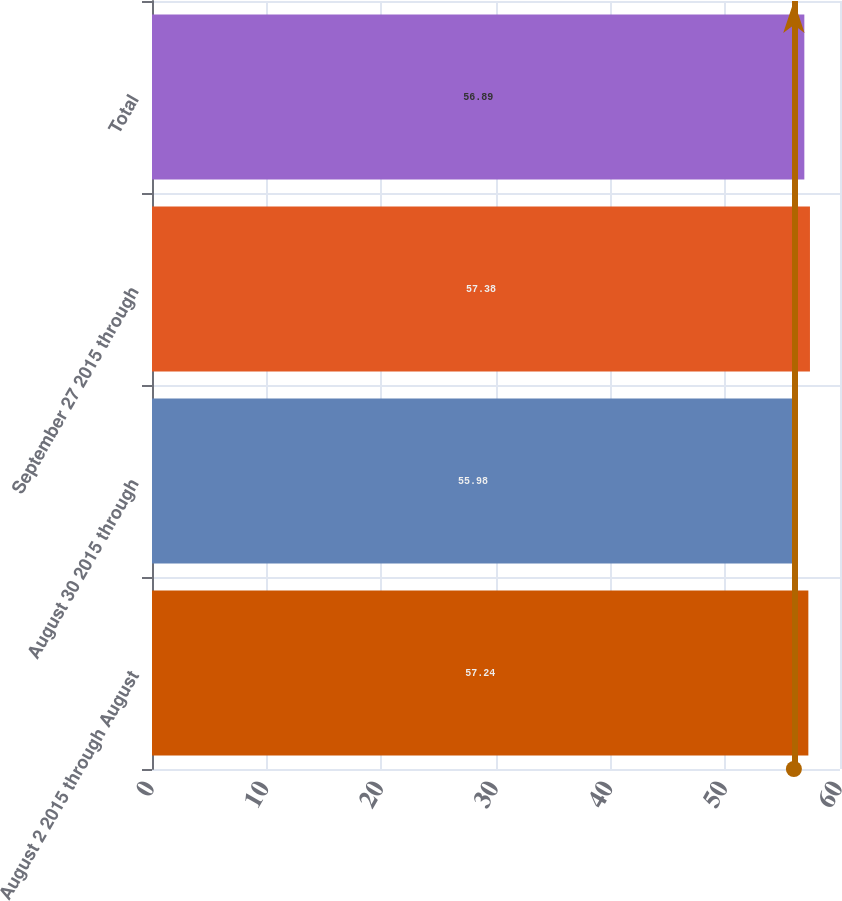Convert chart to OTSL. <chart><loc_0><loc_0><loc_500><loc_500><bar_chart><fcel>August 2 2015 through August<fcel>August 30 2015 through<fcel>September 27 2015 through<fcel>Total<nl><fcel>57.24<fcel>55.98<fcel>57.38<fcel>56.89<nl></chart> 